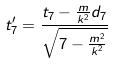<formula> <loc_0><loc_0><loc_500><loc_500>t _ { 7 } ^ { \prime } = \frac { t _ { 7 } - \frac { m } { k ^ { 2 } } d _ { 7 } } { \sqrt { 7 - \frac { m ^ { 2 } } { k ^ { 2 } } } }</formula> 